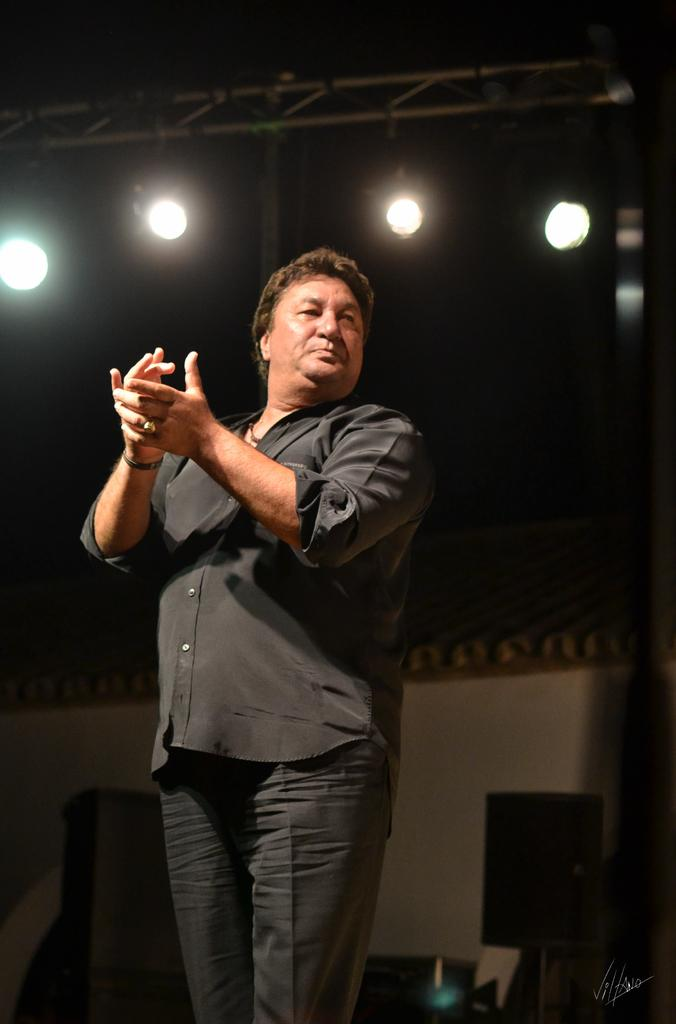What is the main subject of the image? There is a person standing in the image. What is the person doing in the image? The person is clapping their hands. What can be seen in the background of the image? There are lights present on a frame in the background of the image. What type of magic is being performed by the person in the image? There is no indication of magic or any magical performance in the image. The person is simply clapping their hands. 